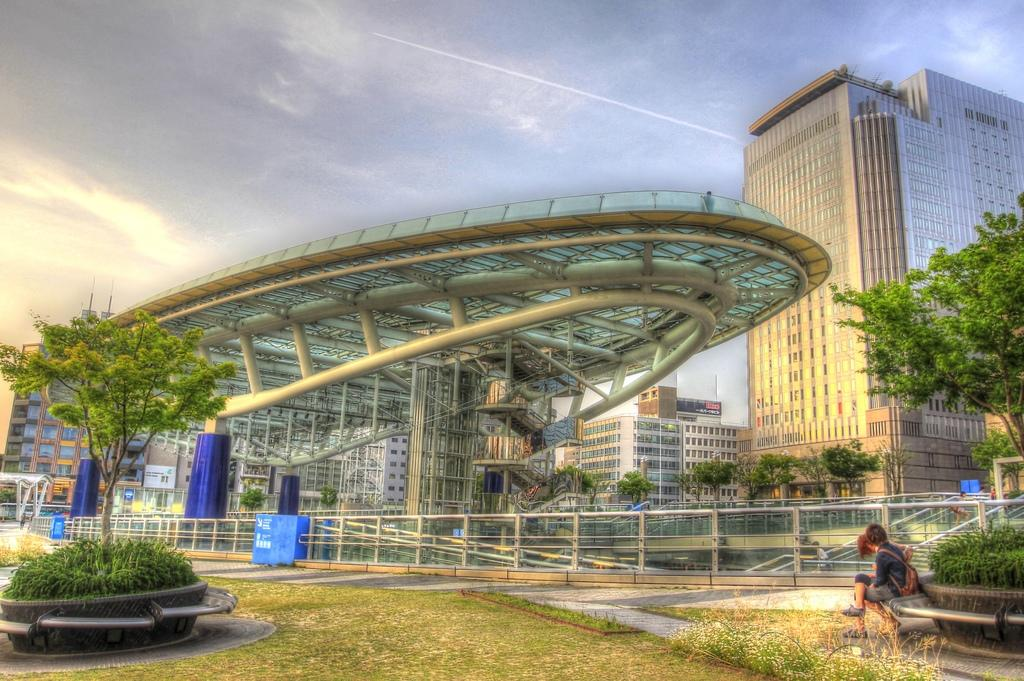How many people are sitting in the image? There are two people sitting in the image. What type of natural environment is visible in the image? There is grass, plants, trees, and sky visible in the image. What type of structures can be seen in the image? There are rods and architecture visible in the image. Can you describe the background of the image? In the background of the image, there are people, buildings, trees, and sky visible. What type of salt is being used by the people in the image? There is no salt present in the image; it features two people sitting in a natural environment with various structures and background elements. 